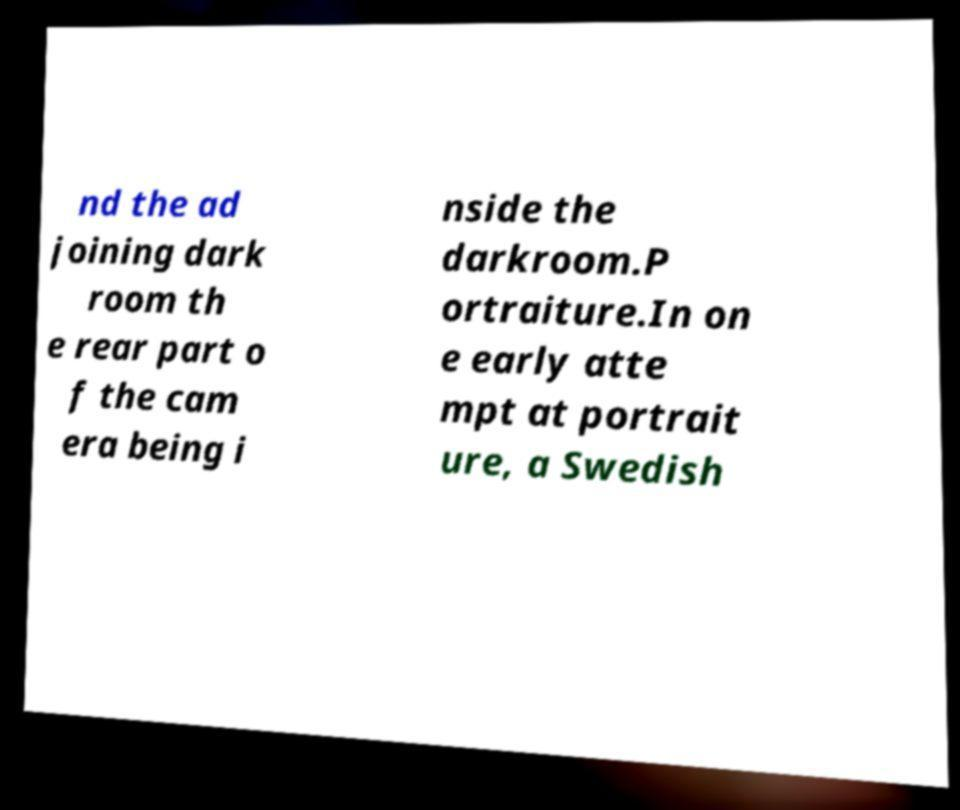There's text embedded in this image that I need extracted. Can you transcribe it verbatim? nd the ad joining dark room th e rear part o f the cam era being i nside the darkroom.P ortraiture.In on e early atte mpt at portrait ure, a Swedish 